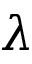<formula> <loc_0><loc_0><loc_500><loc_500>\lambda</formula> 